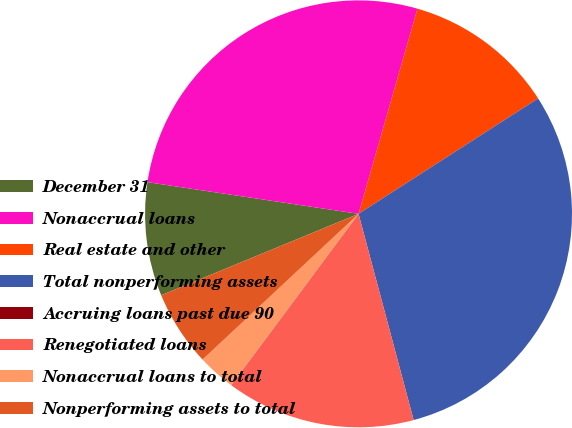<chart> <loc_0><loc_0><loc_500><loc_500><pie_chart><fcel>December 31<fcel>Nonaccrual loans<fcel>Real estate and other<fcel>Total nonperforming assets<fcel>Accruing loans past due 90<fcel>Renegotiated loans<fcel>Nonaccrual loans to total<fcel>Nonperforming assets to total<nl><fcel>8.6%<fcel>27.08%<fcel>11.46%<fcel>29.94%<fcel>0.0%<fcel>14.33%<fcel>2.87%<fcel>5.73%<nl></chart> 